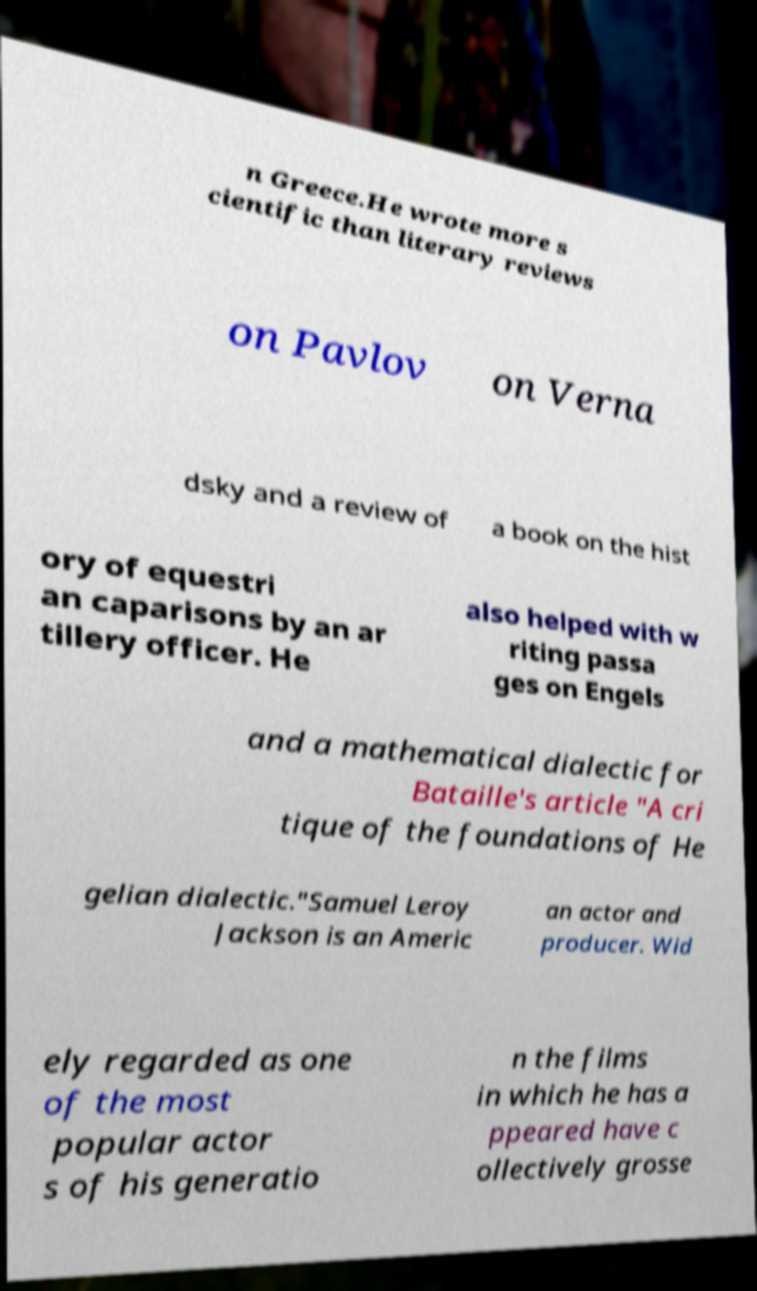Please identify and transcribe the text found in this image. n Greece.He wrote more s cientific than literary reviews on Pavlov on Verna dsky and a review of a book on the hist ory of equestri an caparisons by an ar tillery officer. He also helped with w riting passa ges on Engels and a mathematical dialectic for Bataille's article "A cri tique of the foundations of He gelian dialectic."Samuel Leroy Jackson is an Americ an actor and producer. Wid ely regarded as one of the most popular actor s of his generatio n the films in which he has a ppeared have c ollectively grosse 